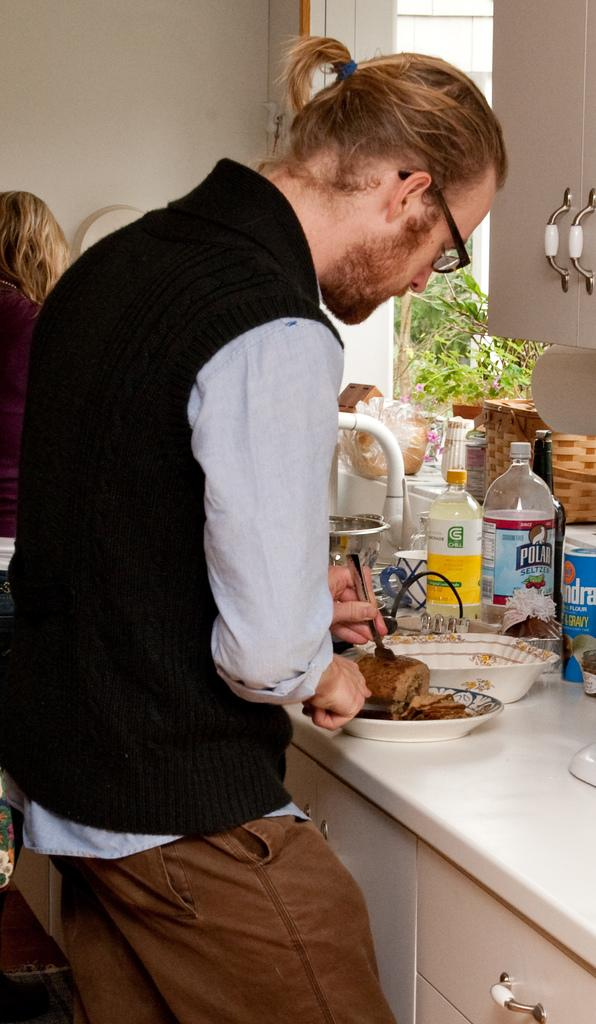<image>
Provide a brief description of the given image. A man puts his fork into food sitting next to Polar Seltzer water. 